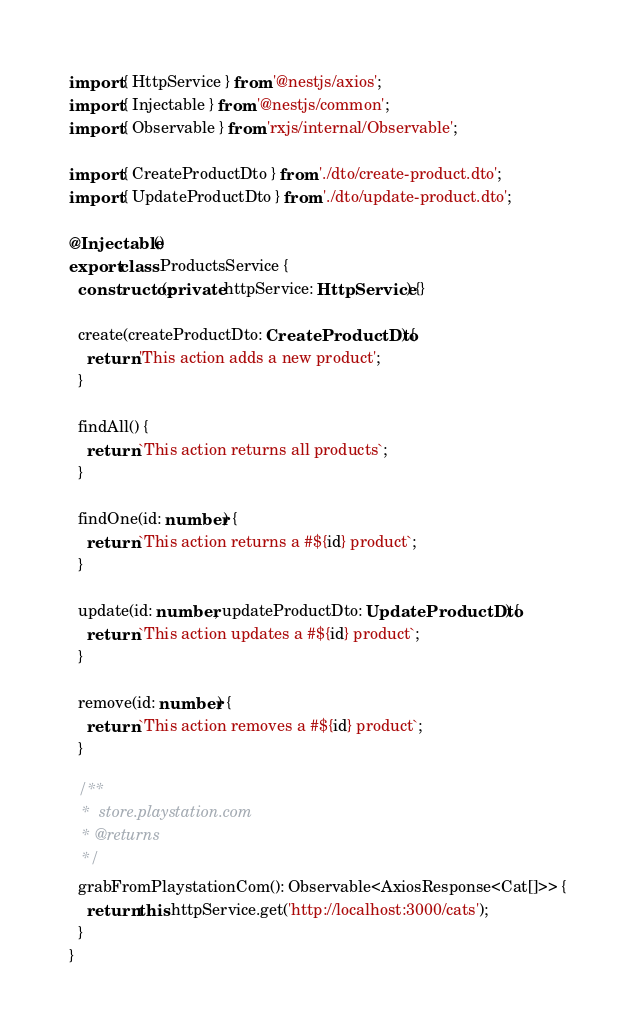Convert code to text. <code><loc_0><loc_0><loc_500><loc_500><_TypeScript_>import { HttpService } from '@nestjs/axios';
import { Injectable } from '@nestjs/common';
import { Observable } from 'rxjs/internal/Observable';

import { CreateProductDto } from './dto/create-product.dto';
import { UpdateProductDto } from './dto/update-product.dto';

@Injectable()
export class ProductsService {
  constructor(private httpService: HttpService) {}

  create(createProductDto: CreateProductDto) {
    return 'This action adds a new product';
  }

  findAll() {
    return `This action returns all products`;
  }

  findOne(id: number) {
    return `This action returns a #${id} product`;
  }

  update(id: number, updateProductDto: UpdateProductDto) {
    return `This action updates a #${id} product`;
  }

  remove(id: number) {
    return `This action removes a #${id} product`;
  }

  /**
   *  store.playstation.com
   * @returns 
   */
  grabFromPlaystationCom(): Observable<AxiosResponse<Cat[]>> {
    return this.httpService.get('http://localhost:3000/cats');
  }
}
</code> 